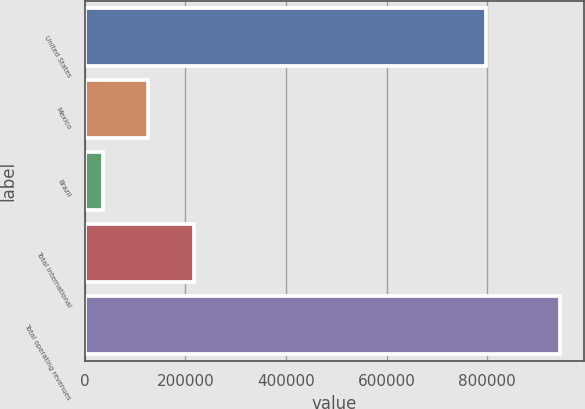<chart> <loc_0><loc_0><loc_500><loc_500><bar_chart><fcel>United States<fcel>Mexico<fcel>Brazil<fcel>Total International<fcel>Total operating revenues<nl><fcel>798010<fcel>126298<fcel>35355<fcel>217241<fcel>944786<nl></chart> 